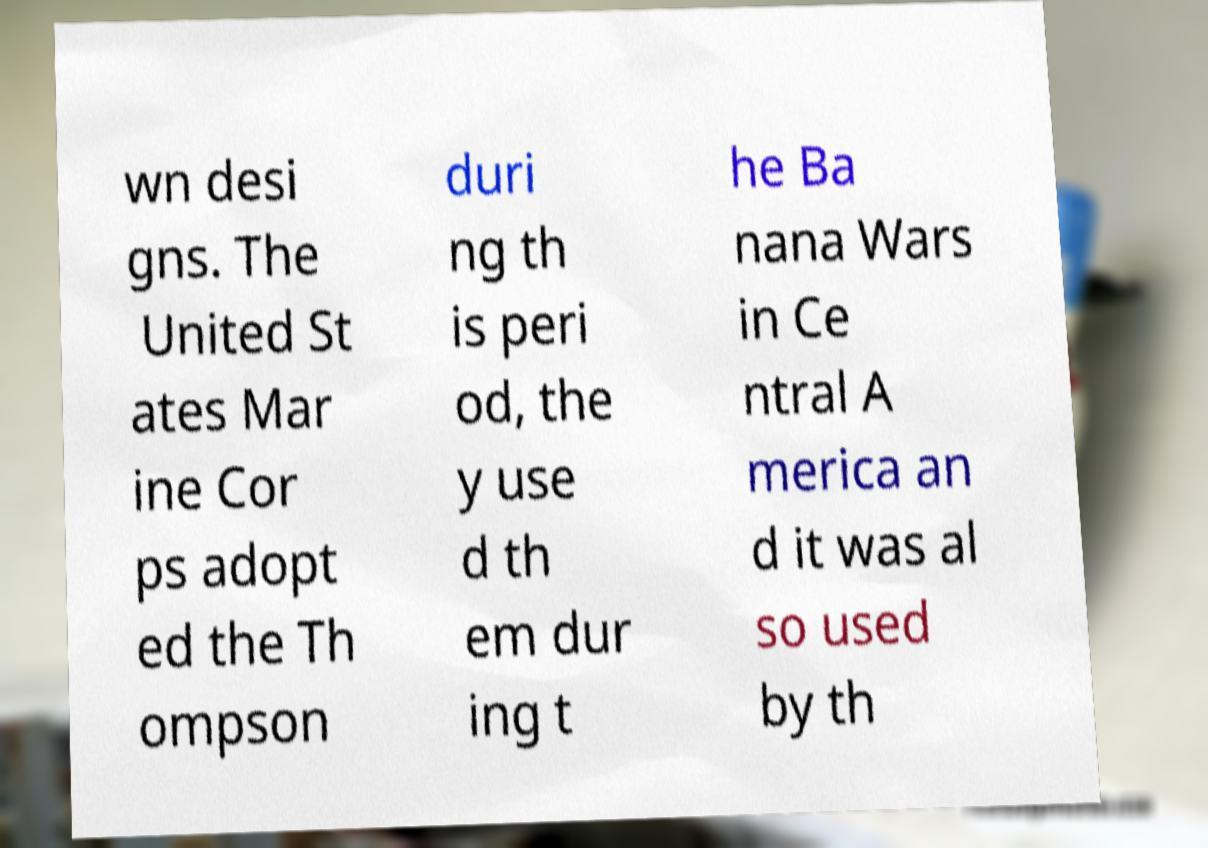Can you read and provide the text displayed in the image?This photo seems to have some interesting text. Can you extract and type it out for me? wn desi gns. The United St ates Mar ine Cor ps adopt ed the Th ompson duri ng th is peri od, the y use d th em dur ing t he Ba nana Wars in Ce ntral A merica an d it was al so used by th 